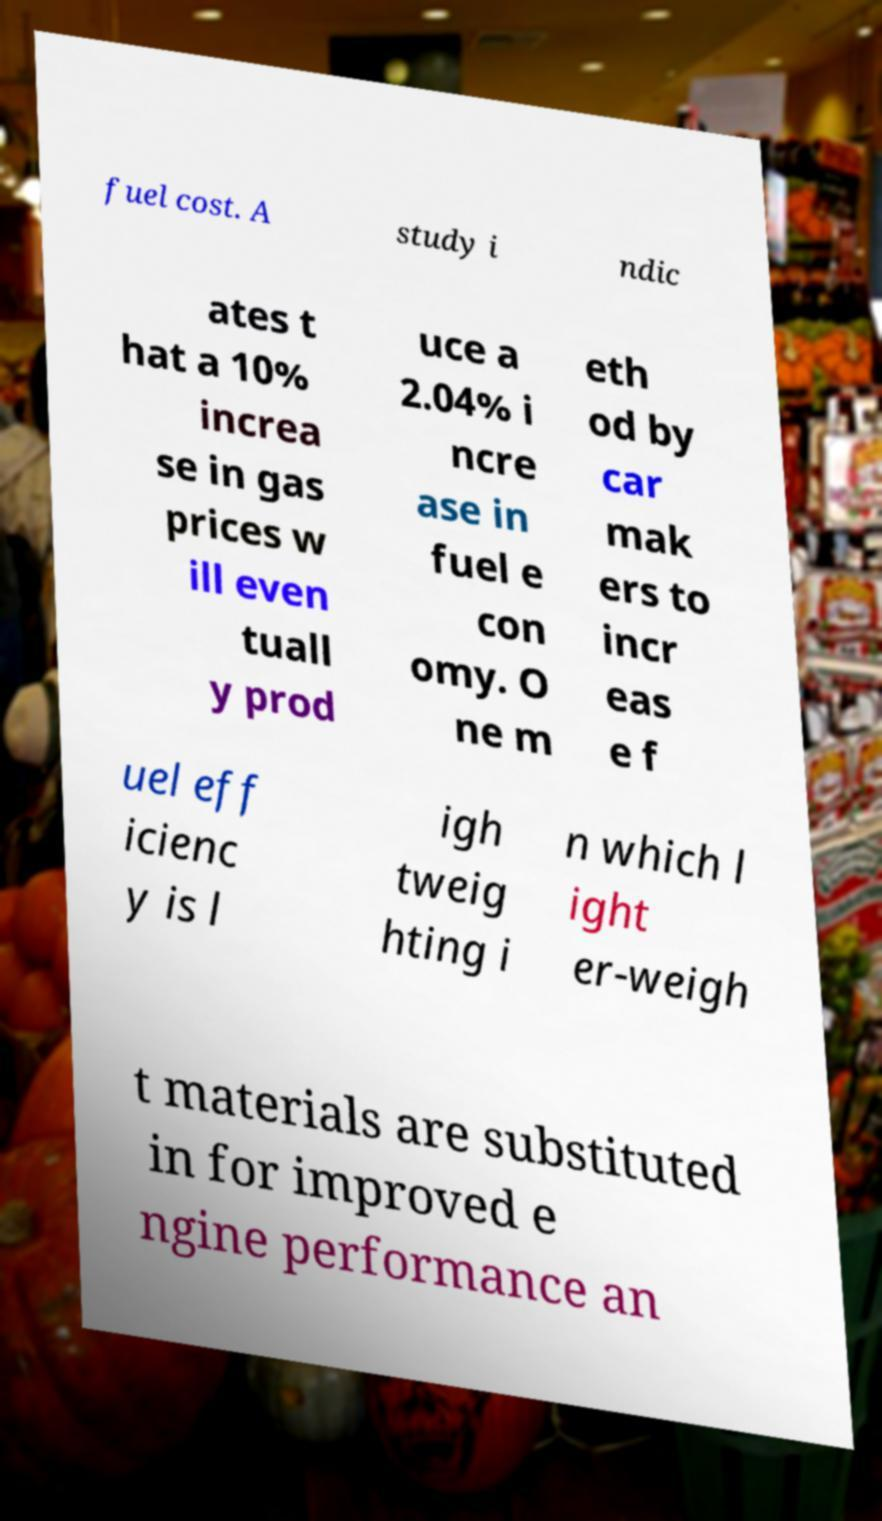Can you accurately transcribe the text from the provided image for me? fuel cost. A study i ndic ates t hat a 10% increa se in gas prices w ill even tuall y prod uce a 2.04% i ncre ase in fuel e con omy. O ne m eth od by car mak ers to incr eas e f uel eff icienc y is l igh tweig hting i n which l ight er-weigh t materials are substituted in for improved e ngine performance an 